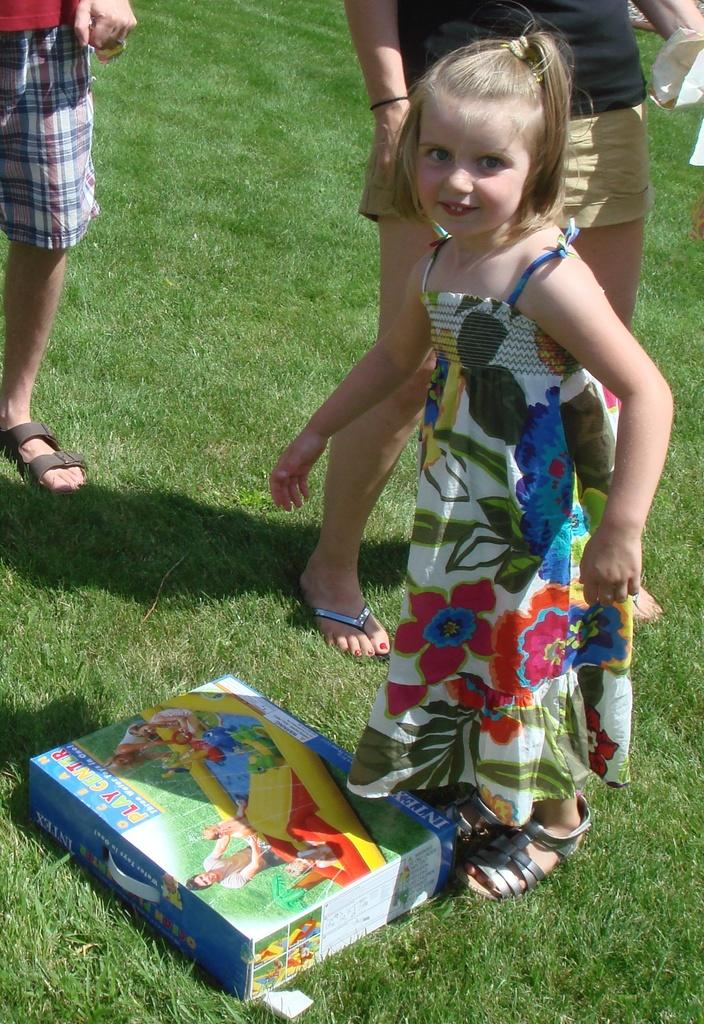What is the main subject of the image? There is a small child in the image. Where is the child located in the image? The child is on the right side of the image. What type of terrain is the child on? The child is on the grassland. What object can be seen on the floor in the image? There is a toy box on the floor in the image. Are there any other people visible in the image? Yes, there are other people behind the child. What type of garden can be seen in the image? There is no garden present in the image. How many cushions are visible in the image? There are no cushions visible in the image. 